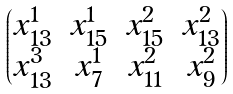<formula> <loc_0><loc_0><loc_500><loc_500>\begin{pmatrix} x _ { 1 3 } ^ { 1 } & x _ { 1 5 } ^ { 1 } & x _ { 1 5 } ^ { 2 } & x _ { 1 3 } ^ { 2 } \\ x _ { 1 3 } ^ { 3 } & x _ { 7 } ^ { 1 } & x _ { 1 1 } ^ { 2 } & x _ { 9 } ^ { 2 } \end{pmatrix}</formula> 